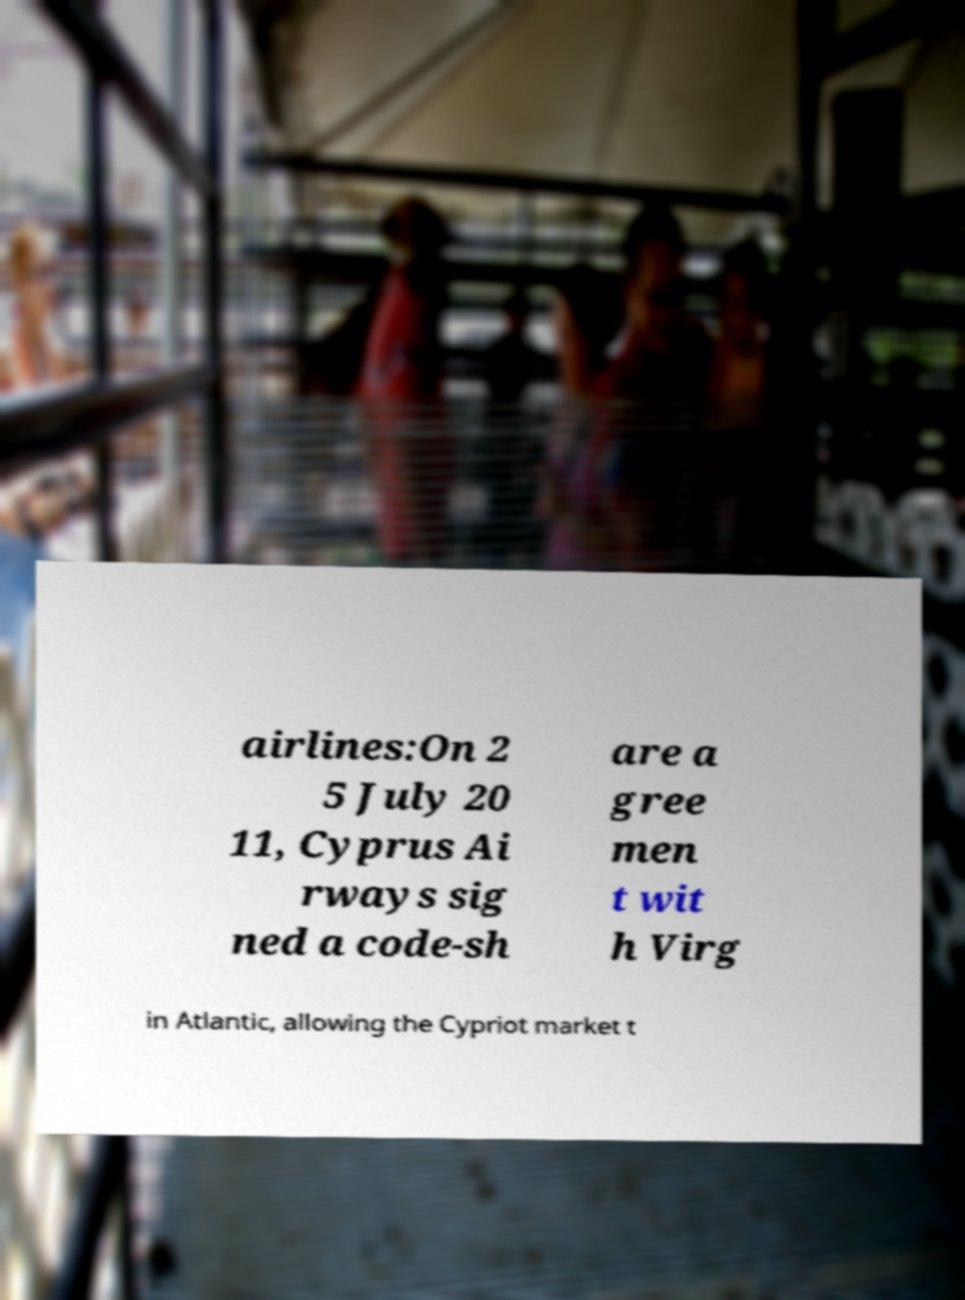Please identify and transcribe the text found in this image. airlines:On 2 5 July 20 11, Cyprus Ai rways sig ned a code-sh are a gree men t wit h Virg in Atlantic, allowing the Cypriot market t 